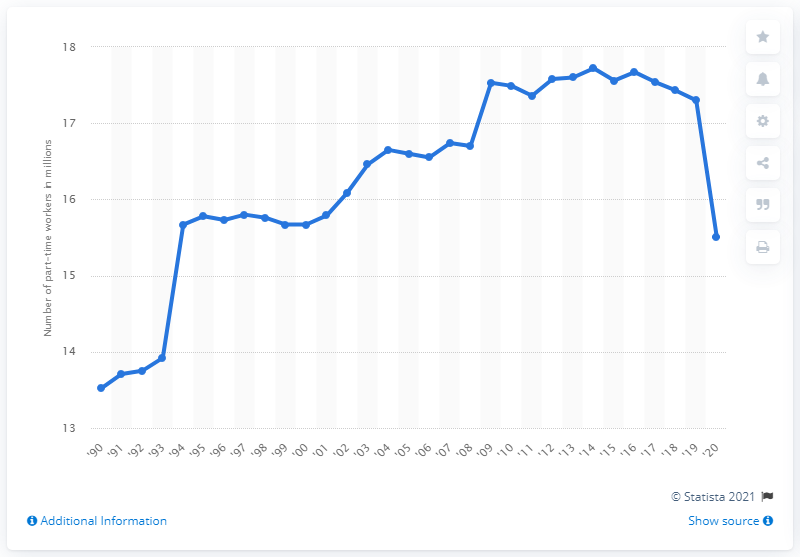Specify some key components in this picture. In 2020, 15.51 women were employed on a part-time basis. 